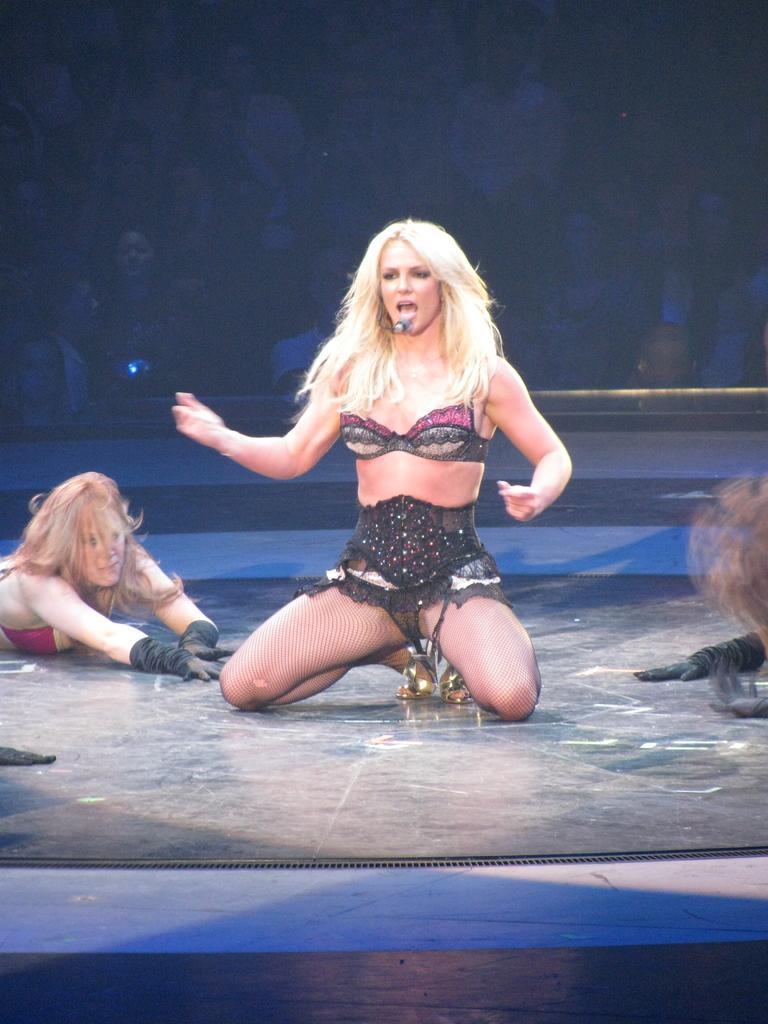Can you describe this image briefly? In this image I can see two women. In the background I can see few people. 